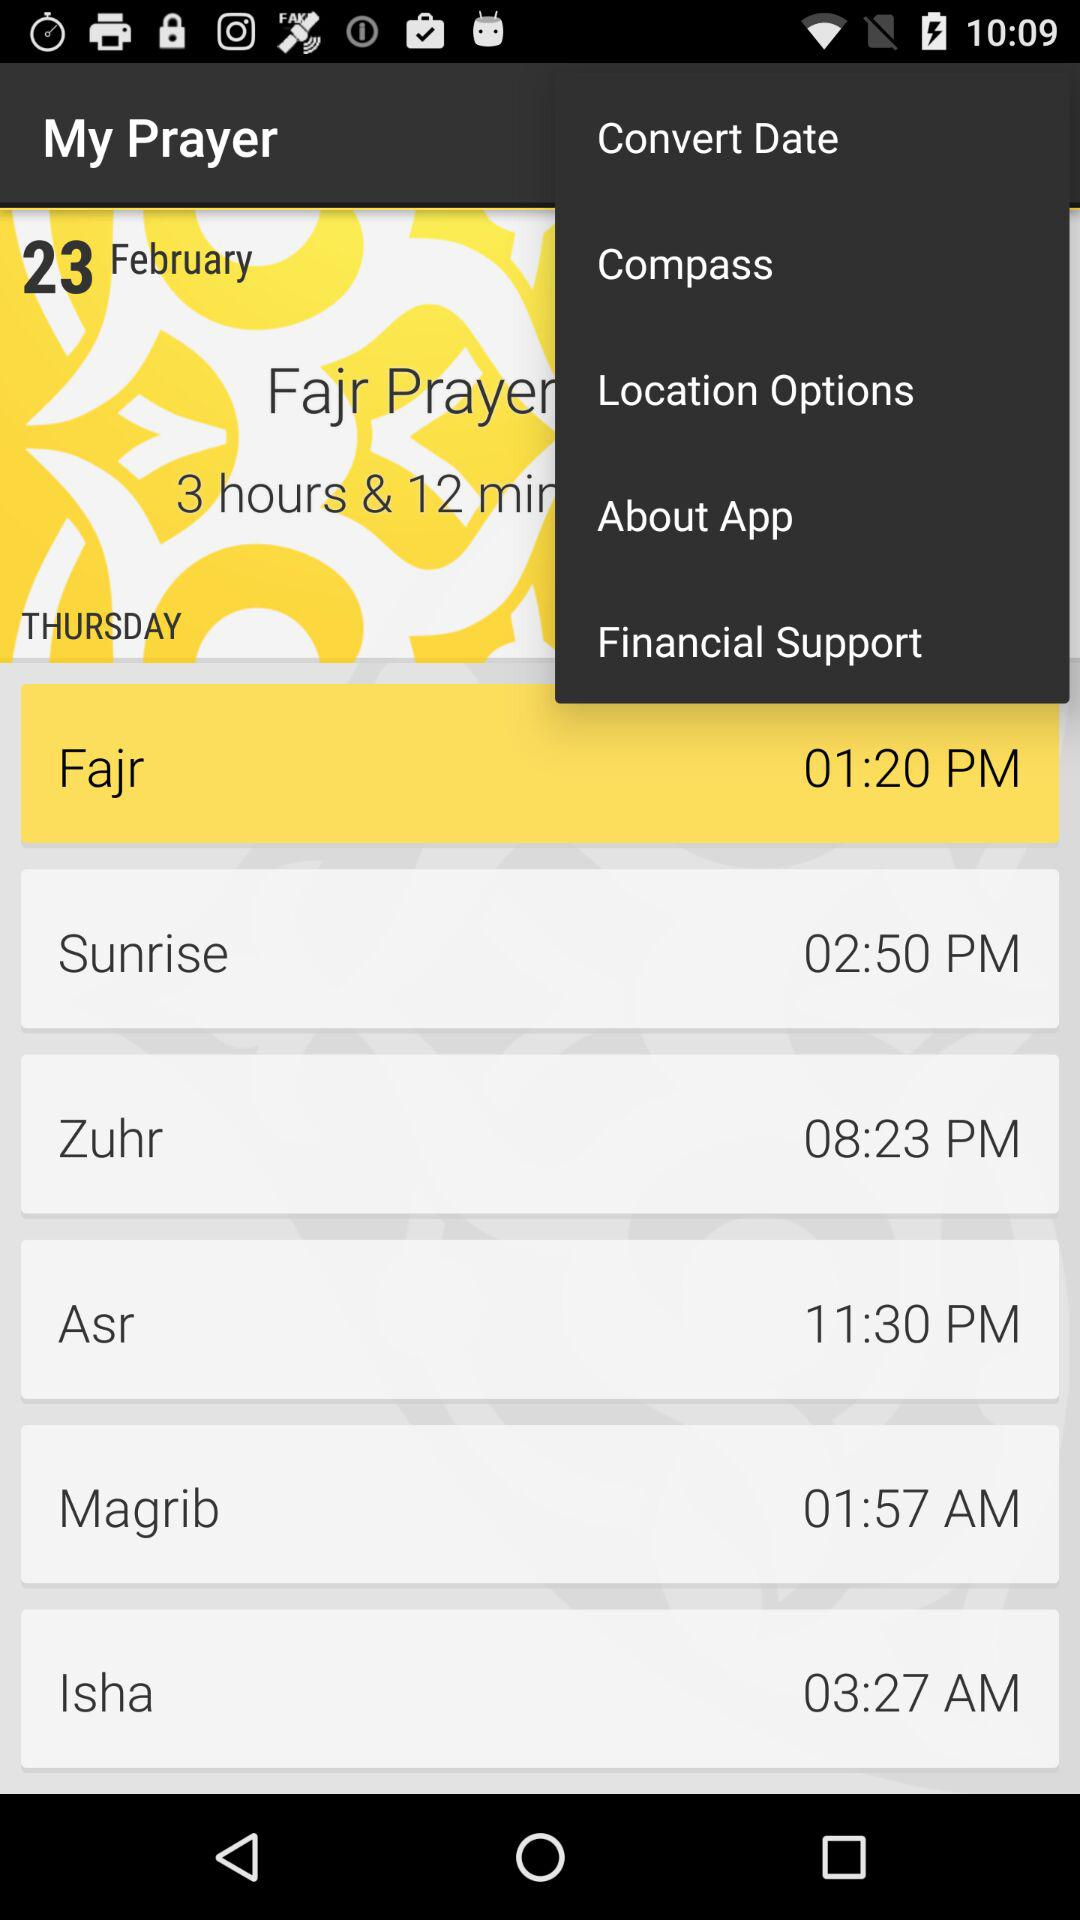What is the given date? The given date is Thursday, February 23. 